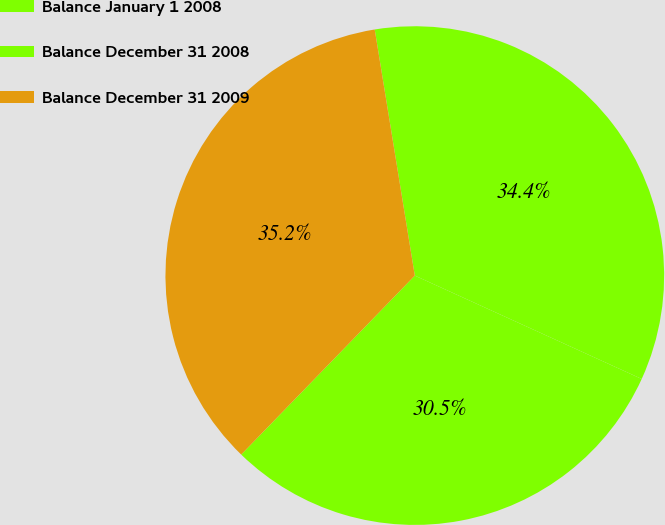Convert chart to OTSL. <chart><loc_0><loc_0><loc_500><loc_500><pie_chart><fcel>Balance January 1 2008<fcel>Balance December 31 2008<fcel>Balance December 31 2009<nl><fcel>30.45%<fcel>34.37%<fcel>35.17%<nl></chart> 